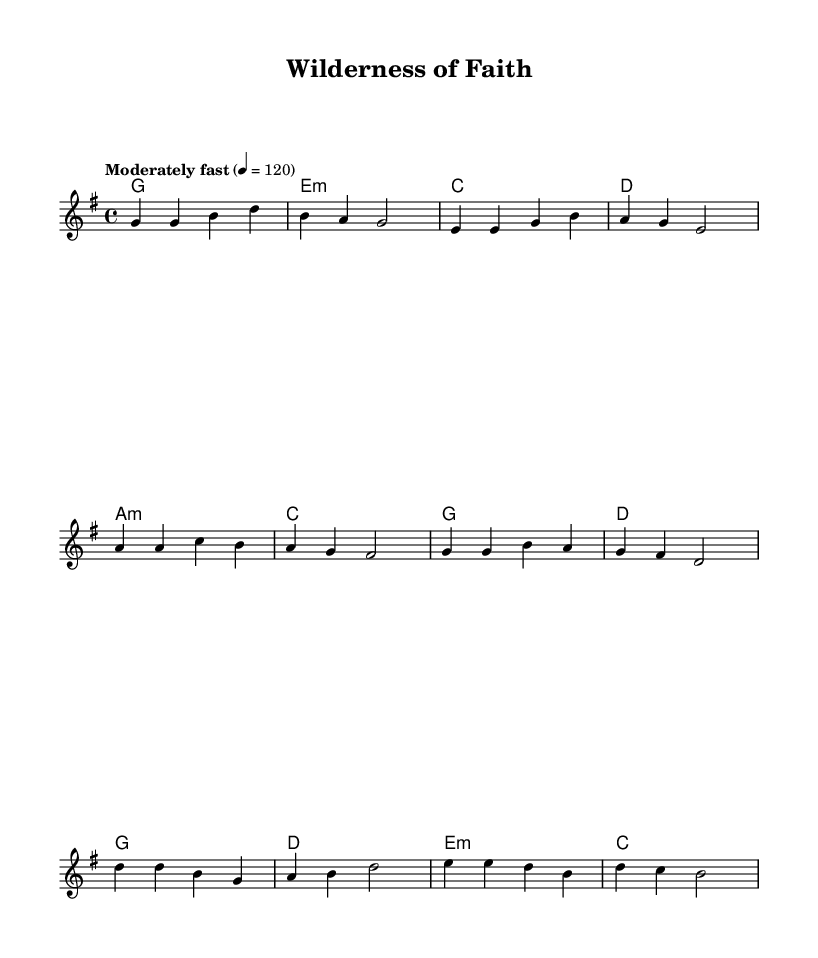What is the key signature of this music? The key signature is G major, which has one sharp (F#). This can be identified in the global block of the code, where the notation \key g \major is specified.
Answer: G major What is the time signature of this music? The time signature is 4/4. This is indicated in the global block of the code with the notation \time 4/4, meaning there are four beats per measure.
Answer: 4/4 What is the tempo marking of this music? The tempo marking is "Moderately fast" with a beat of 120. The tempo information can be found by looking at the notation in the global block, where it is specified as 4 = 120.
Answer: Moderately fast What is the main theme conveyed in the chorus? The main theme of the chorus revolves around faith and the experience of grace discovered in nature. The lyrics emphasize the spiritual journey reflected through natural imagery. The chorus lyrics clearly mention “In the wilderness of faith, I find Your grace,” indicating this theme.
Answer: Wilderness of faith How many bars are there in the verse? The verse consists of four bars. By counting the vertical lines between the notes in the verse section of the melody part, we can see that there are four measures.
Answer: Four What metaphorical concepts are present in the pre-chorus? The pre-chorus uses metaphors of climbing and guidance, suggesting a spiritual aspiration and divine assistance. The lyrics "Climbing higher, reaching far, Guided by His morning star" highlight these concepts. This illustrates the idea of striving towards spiritual goals with divine support.
Answer: Climbing and guidance How does the structure of this song support its spiritual themes? The song structure includes verses, a pre-chorus, and a chorus, creating a narrative that reflects a journey of faith. Each section builds on the last, with the verse establishing the quest for truth and the chorus culminating in the realization of grace. This progression mirrors a spiritual journey often found in Christian rock.
Answer: Narrative of faith journey 